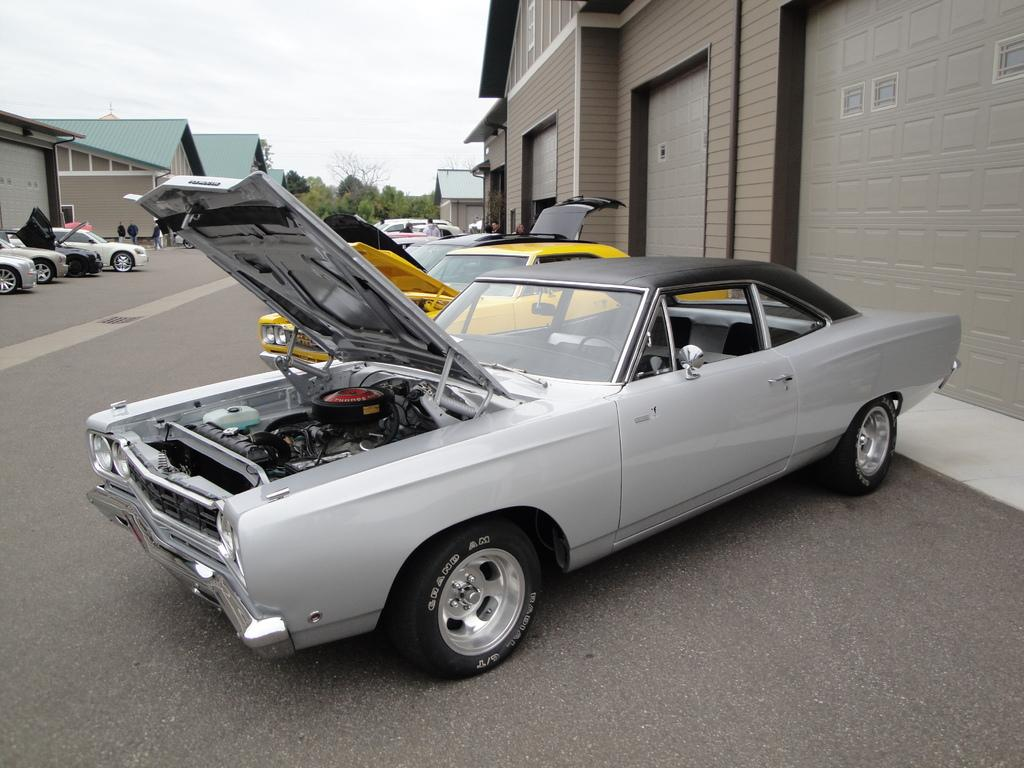What can be seen on the road in the image? There are fleets of cars on the road in the image. What else is present in the image besides the cars? There is a crowd in the image. What can be seen in the background of the image? There are buildings, trees, and the sky visible in the background of the image. When was the image taken? The image was taken during the day. What type of rice is being served at the cemetery in the image? There is no cemetery or rice present in the image. How far away is the crowd from the buildings in the image? The distance between the crowd and the buildings cannot be determined from the image. 